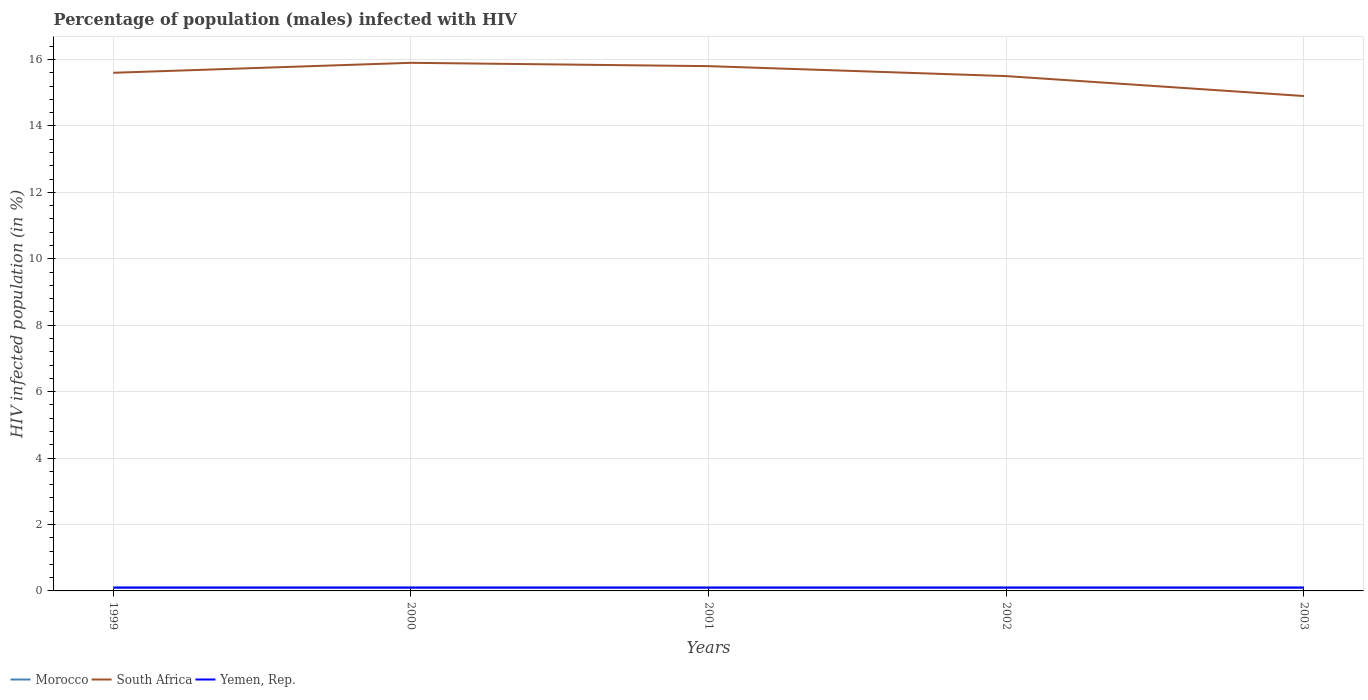How many different coloured lines are there?
Offer a terse response. 3. Across all years, what is the maximum percentage of HIV infected male population in South Africa?
Keep it short and to the point. 14.9. In which year was the percentage of HIV infected male population in Morocco maximum?
Provide a short and direct response. 1999. What is the difference between the highest and the lowest percentage of HIV infected male population in Morocco?
Provide a succinct answer. 0. Is the percentage of HIV infected male population in South Africa strictly greater than the percentage of HIV infected male population in Morocco over the years?
Provide a succinct answer. No. How many lines are there?
Provide a succinct answer. 3. Does the graph contain grids?
Provide a short and direct response. Yes. Where does the legend appear in the graph?
Keep it short and to the point. Bottom left. How many legend labels are there?
Your response must be concise. 3. What is the title of the graph?
Provide a short and direct response. Percentage of population (males) infected with HIV. What is the label or title of the Y-axis?
Offer a very short reply. HIV infected population (in %). What is the HIV infected population (in %) of Morocco in 1999?
Provide a short and direct response. 0.1. What is the HIV infected population (in %) in Yemen, Rep. in 1999?
Make the answer very short. 0.1. What is the HIV infected population (in %) in Morocco in 2000?
Give a very brief answer. 0.1. What is the HIV infected population (in %) in South Africa in 2000?
Give a very brief answer. 15.9. What is the HIV infected population (in %) of Yemen, Rep. in 2000?
Give a very brief answer. 0.1. What is the HIV infected population (in %) of Morocco in 2002?
Keep it short and to the point. 0.1. What is the HIV infected population (in %) of Yemen, Rep. in 2002?
Offer a terse response. 0.1. What is the HIV infected population (in %) of Morocco in 2003?
Your answer should be compact. 0.1. Across all years, what is the maximum HIV infected population (in %) of Yemen, Rep.?
Provide a succinct answer. 0.1. Across all years, what is the minimum HIV infected population (in %) of Morocco?
Give a very brief answer. 0.1. What is the total HIV infected population (in %) in Morocco in the graph?
Ensure brevity in your answer.  0.5. What is the total HIV infected population (in %) of South Africa in the graph?
Offer a terse response. 77.7. What is the difference between the HIV infected population (in %) of South Africa in 1999 and that in 2000?
Keep it short and to the point. -0.3. What is the difference between the HIV infected population (in %) in Yemen, Rep. in 1999 and that in 2000?
Your answer should be very brief. 0. What is the difference between the HIV infected population (in %) of Morocco in 1999 and that in 2001?
Keep it short and to the point. 0. What is the difference between the HIV infected population (in %) in Morocco in 2000 and that in 2001?
Provide a succinct answer. 0. What is the difference between the HIV infected population (in %) of South Africa in 2000 and that in 2001?
Provide a short and direct response. 0.1. What is the difference between the HIV infected population (in %) of Yemen, Rep. in 2000 and that in 2001?
Your answer should be very brief. 0. What is the difference between the HIV infected population (in %) in Yemen, Rep. in 2000 and that in 2002?
Provide a succinct answer. 0. What is the difference between the HIV infected population (in %) in Morocco in 2000 and that in 2003?
Your response must be concise. 0. What is the difference between the HIV infected population (in %) of South Africa in 2000 and that in 2003?
Your answer should be very brief. 1. What is the difference between the HIV infected population (in %) of Morocco in 2001 and that in 2002?
Your response must be concise. 0. What is the difference between the HIV infected population (in %) in South Africa in 2001 and that in 2002?
Make the answer very short. 0.3. What is the difference between the HIV infected population (in %) in Yemen, Rep. in 2001 and that in 2002?
Your answer should be very brief. 0. What is the difference between the HIV infected population (in %) of Morocco in 2001 and that in 2003?
Keep it short and to the point. 0. What is the difference between the HIV infected population (in %) in Yemen, Rep. in 2001 and that in 2003?
Give a very brief answer. 0. What is the difference between the HIV infected population (in %) of Morocco in 2002 and that in 2003?
Provide a succinct answer. 0. What is the difference between the HIV infected population (in %) of Yemen, Rep. in 2002 and that in 2003?
Offer a terse response. 0. What is the difference between the HIV infected population (in %) in Morocco in 1999 and the HIV infected population (in %) in South Africa in 2000?
Give a very brief answer. -15.8. What is the difference between the HIV infected population (in %) of South Africa in 1999 and the HIV infected population (in %) of Yemen, Rep. in 2000?
Provide a succinct answer. 15.5. What is the difference between the HIV infected population (in %) in Morocco in 1999 and the HIV infected population (in %) in South Africa in 2001?
Keep it short and to the point. -15.7. What is the difference between the HIV infected population (in %) of South Africa in 1999 and the HIV infected population (in %) of Yemen, Rep. in 2001?
Offer a terse response. 15.5. What is the difference between the HIV infected population (in %) of Morocco in 1999 and the HIV infected population (in %) of South Africa in 2002?
Keep it short and to the point. -15.4. What is the difference between the HIV infected population (in %) of South Africa in 1999 and the HIV infected population (in %) of Yemen, Rep. in 2002?
Offer a very short reply. 15.5. What is the difference between the HIV infected population (in %) of Morocco in 1999 and the HIV infected population (in %) of South Africa in 2003?
Offer a very short reply. -14.8. What is the difference between the HIV infected population (in %) in Morocco in 1999 and the HIV infected population (in %) in Yemen, Rep. in 2003?
Your answer should be very brief. 0. What is the difference between the HIV infected population (in %) in Morocco in 2000 and the HIV infected population (in %) in South Africa in 2001?
Offer a terse response. -15.7. What is the difference between the HIV infected population (in %) in Morocco in 2000 and the HIV infected population (in %) in Yemen, Rep. in 2001?
Your answer should be very brief. 0. What is the difference between the HIV infected population (in %) of South Africa in 2000 and the HIV infected population (in %) of Yemen, Rep. in 2001?
Keep it short and to the point. 15.8. What is the difference between the HIV infected population (in %) in Morocco in 2000 and the HIV infected population (in %) in South Africa in 2002?
Offer a terse response. -15.4. What is the difference between the HIV infected population (in %) of Morocco in 2000 and the HIV infected population (in %) of South Africa in 2003?
Provide a short and direct response. -14.8. What is the difference between the HIV infected population (in %) of South Africa in 2000 and the HIV infected population (in %) of Yemen, Rep. in 2003?
Keep it short and to the point. 15.8. What is the difference between the HIV infected population (in %) of Morocco in 2001 and the HIV infected population (in %) of South Africa in 2002?
Your answer should be very brief. -15.4. What is the difference between the HIV infected population (in %) of Morocco in 2001 and the HIV infected population (in %) of South Africa in 2003?
Your response must be concise. -14.8. What is the difference between the HIV infected population (in %) of South Africa in 2001 and the HIV infected population (in %) of Yemen, Rep. in 2003?
Provide a short and direct response. 15.7. What is the difference between the HIV infected population (in %) of Morocco in 2002 and the HIV infected population (in %) of South Africa in 2003?
Ensure brevity in your answer.  -14.8. What is the difference between the HIV infected population (in %) of South Africa in 2002 and the HIV infected population (in %) of Yemen, Rep. in 2003?
Offer a terse response. 15.4. What is the average HIV infected population (in %) in South Africa per year?
Give a very brief answer. 15.54. In the year 1999, what is the difference between the HIV infected population (in %) of Morocco and HIV infected population (in %) of South Africa?
Your answer should be compact. -15.5. In the year 1999, what is the difference between the HIV infected population (in %) of South Africa and HIV infected population (in %) of Yemen, Rep.?
Ensure brevity in your answer.  15.5. In the year 2000, what is the difference between the HIV infected population (in %) of Morocco and HIV infected population (in %) of South Africa?
Keep it short and to the point. -15.8. In the year 2000, what is the difference between the HIV infected population (in %) of South Africa and HIV infected population (in %) of Yemen, Rep.?
Offer a very short reply. 15.8. In the year 2001, what is the difference between the HIV infected population (in %) of Morocco and HIV infected population (in %) of South Africa?
Give a very brief answer. -15.7. In the year 2001, what is the difference between the HIV infected population (in %) of South Africa and HIV infected population (in %) of Yemen, Rep.?
Offer a very short reply. 15.7. In the year 2002, what is the difference between the HIV infected population (in %) of Morocco and HIV infected population (in %) of South Africa?
Offer a terse response. -15.4. In the year 2003, what is the difference between the HIV infected population (in %) in Morocco and HIV infected population (in %) in South Africa?
Offer a terse response. -14.8. In the year 2003, what is the difference between the HIV infected population (in %) in Morocco and HIV infected population (in %) in Yemen, Rep.?
Give a very brief answer. 0. In the year 2003, what is the difference between the HIV infected population (in %) in South Africa and HIV infected population (in %) in Yemen, Rep.?
Ensure brevity in your answer.  14.8. What is the ratio of the HIV infected population (in %) of South Africa in 1999 to that in 2000?
Your answer should be very brief. 0.98. What is the ratio of the HIV infected population (in %) of Morocco in 1999 to that in 2001?
Offer a terse response. 1. What is the ratio of the HIV infected population (in %) in South Africa in 1999 to that in 2001?
Your answer should be very brief. 0.99. What is the ratio of the HIV infected population (in %) of Yemen, Rep. in 1999 to that in 2001?
Your answer should be compact. 1. What is the ratio of the HIV infected population (in %) in Morocco in 1999 to that in 2003?
Keep it short and to the point. 1. What is the ratio of the HIV infected population (in %) of South Africa in 1999 to that in 2003?
Provide a short and direct response. 1.05. What is the ratio of the HIV infected population (in %) in Yemen, Rep. in 1999 to that in 2003?
Your response must be concise. 1. What is the ratio of the HIV infected population (in %) of Yemen, Rep. in 2000 to that in 2001?
Offer a very short reply. 1. What is the ratio of the HIV infected population (in %) in South Africa in 2000 to that in 2002?
Ensure brevity in your answer.  1.03. What is the ratio of the HIV infected population (in %) in Yemen, Rep. in 2000 to that in 2002?
Your answer should be very brief. 1. What is the ratio of the HIV infected population (in %) in Morocco in 2000 to that in 2003?
Keep it short and to the point. 1. What is the ratio of the HIV infected population (in %) of South Africa in 2000 to that in 2003?
Provide a succinct answer. 1.07. What is the ratio of the HIV infected population (in %) of Morocco in 2001 to that in 2002?
Offer a very short reply. 1. What is the ratio of the HIV infected population (in %) of South Africa in 2001 to that in 2002?
Make the answer very short. 1.02. What is the ratio of the HIV infected population (in %) in South Africa in 2001 to that in 2003?
Provide a short and direct response. 1.06. What is the ratio of the HIV infected population (in %) of Morocco in 2002 to that in 2003?
Your response must be concise. 1. What is the ratio of the HIV infected population (in %) of South Africa in 2002 to that in 2003?
Your response must be concise. 1.04. What is the difference between the highest and the second highest HIV infected population (in %) in Morocco?
Offer a very short reply. 0. What is the difference between the highest and the second highest HIV infected population (in %) of South Africa?
Offer a terse response. 0.1. What is the difference between the highest and the lowest HIV infected population (in %) of Morocco?
Give a very brief answer. 0. What is the difference between the highest and the lowest HIV infected population (in %) in South Africa?
Offer a terse response. 1. What is the difference between the highest and the lowest HIV infected population (in %) in Yemen, Rep.?
Make the answer very short. 0. 